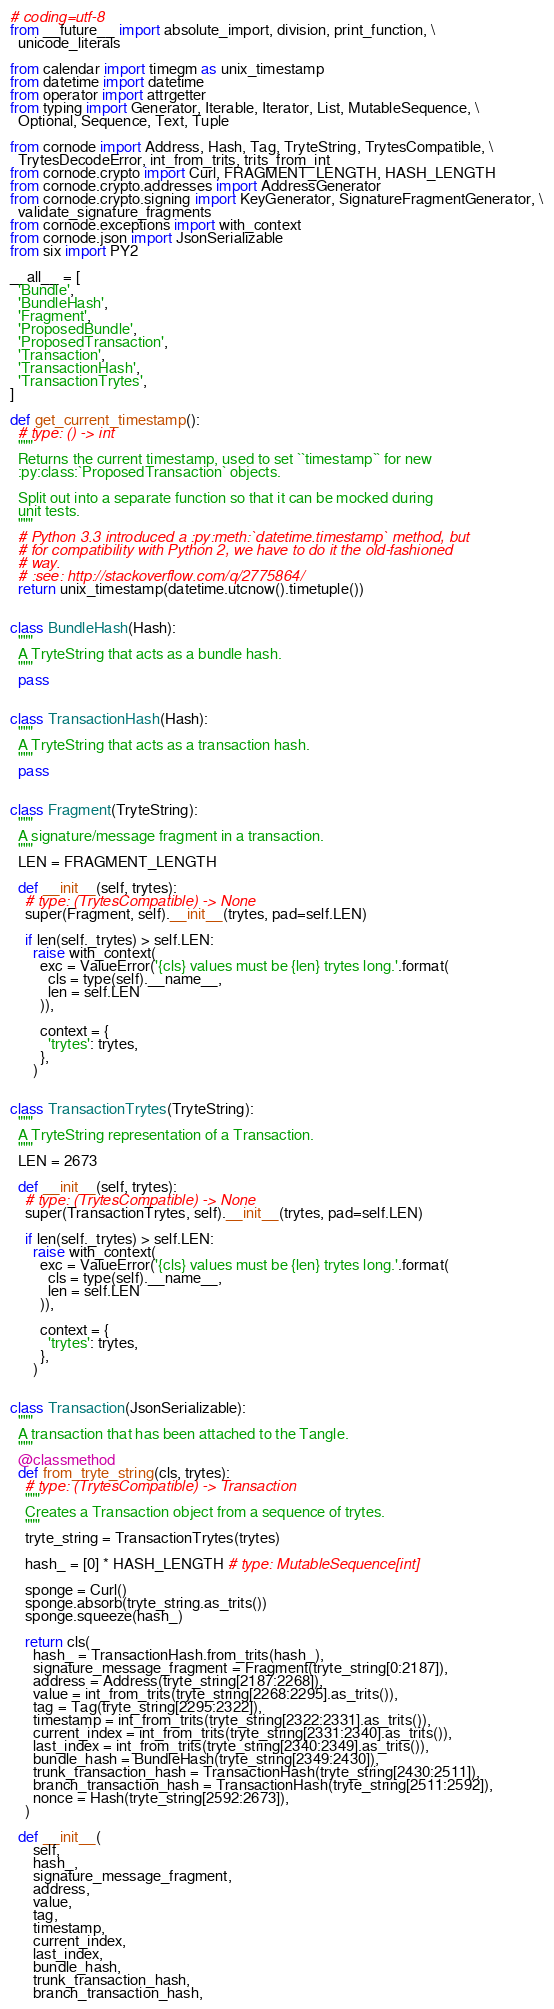<code> <loc_0><loc_0><loc_500><loc_500><_Python_># coding=utf-8
from __future__ import absolute_import, division, print_function, \
  unicode_literals

from calendar import timegm as unix_timestamp
from datetime import datetime
from operator import attrgetter
from typing import Generator, Iterable, Iterator, List, MutableSequence, \
  Optional, Sequence, Text, Tuple

from cornode import Address, Hash, Tag, TryteString, TrytesCompatible, \
  TrytesDecodeError, int_from_trits, trits_from_int
from cornode.crypto import Curl, FRAGMENT_LENGTH, HASH_LENGTH
from cornode.crypto.addresses import AddressGenerator
from cornode.crypto.signing import KeyGenerator, SignatureFragmentGenerator, \
  validate_signature_fragments
from cornode.exceptions import with_context
from cornode.json import JsonSerializable
from six import PY2

__all__ = [
  'Bundle',
  'BundleHash',
  'Fragment',
  'ProposedBundle',
  'ProposedTransaction',
  'Transaction',
  'TransactionHash',
  'TransactionTrytes',
]

def get_current_timestamp():
  # type: () -> int
  """
  Returns the current timestamp, used to set ``timestamp`` for new
  :py:class:`ProposedTransaction` objects.

  Split out into a separate function so that it can be mocked during
  unit tests.
  """
  # Python 3.3 introduced a :py:meth:`datetime.timestamp` method, but
  # for compatibility with Python 2, we have to do it the old-fashioned
  # way.
  # :see: http://stackoverflow.com/q/2775864/
  return unix_timestamp(datetime.utcnow().timetuple())


class BundleHash(Hash):
  """
  A TryteString that acts as a bundle hash.
  """
  pass


class TransactionHash(Hash):
  """
  A TryteString that acts as a transaction hash.
  """
  pass


class Fragment(TryteString):
  """
  A signature/message fragment in a transaction.
  """
  LEN = FRAGMENT_LENGTH

  def __init__(self, trytes):
    # type: (TrytesCompatible) -> None
    super(Fragment, self).__init__(trytes, pad=self.LEN)

    if len(self._trytes) > self.LEN:
      raise with_context(
        exc = ValueError('{cls} values must be {len} trytes long.'.format(
          cls = type(self).__name__,
          len = self.LEN
        )),

        context = {
          'trytes': trytes,
        },
      )


class TransactionTrytes(TryteString):
  """
  A TryteString representation of a Transaction.
  """
  LEN = 2673

  def __init__(self, trytes):
    # type: (TrytesCompatible) -> None
    super(TransactionTrytes, self).__init__(trytes, pad=self.LEN)

    if len(self._trytes) > self.LEN:
      raise with_context(
        exc = ValueError('{cls} values must be {len} trytes long.'.format(
          cls = type(self).__name__,
          len = self.LEN
        )),

        context = {
          'trytes': trytes,
        },
      )


class Transaction(JsonSerializable):
  """
  A transaction that has been attached to the Tangle.
  """
  @classmethod
  def from_tryte_string(cls, trytes):
    # type: (TrytesCompatible) -> Transaction
    """
    Creates a Transaction object from a sequence of trytes.
    """
    tryte_string = TransactionTrytes(trytes)

    hash_ = [0] * HASH_LENGTH # type: MutableSequence[int]

    sponge = Curl()
    sponge.absorb(tryte_string.as_trits())
    sponge.squeeze(hash_)

    return cls(
      hash_ = TransactionHash.from_trits(hash_),
      signature_message_fragment = Fragment(tryte_string[0:2187]),
      address = Address(tryte_string[2187:2268]),
      value = int_from_trits(tryte_string[2268:2295].as_trits()),
      tag = Tag(tryte_string[2295:2322]),
      timestamp = int_from_trits(tryte_string[2322:2331].as_trits()),
      current_index = int_from_trits(tryte_string[2331:2340].as_trits()),
      last_index = int_from_trits(tryte_string[2340:2349].as_trits()),
      bundle_hash = BundleHash(tryte_string[2349:2430]),
      trunk_transaction_hash = TransactionHash(tryte_string[2430:2511]),
      branch_transaction_hash = TransactionHash(tryte_string[2511:2592]),
      nonce = Hash(tryte_string[2592:2673]),
    )

  def __init__(
      self,
      hash_,
      signature_message_fragment,
      address,
      value,
      tag,
      timestamp,
      current_index,
      last_index,
      bundle_hash,
      trunk_transaction_hash,
      branch_transaction_hash,</code> 